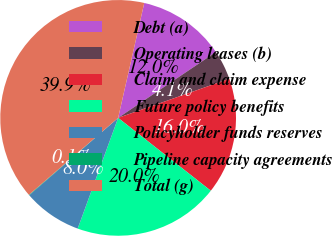Convert chart. <chart><loc_0><loc_0><loc_500><loc_500><pie_chart><fcel>Debt (a)<fcel>Operating leases (b)<fcel>Claim and claim expense<fcel>Future policy benefits<fcel>Policyholder funds reserves<fcel>Pipeline capacity agreements<fcel>Total (g)<nl><fcel>12.01%<fcel>4.05%<fcel>15.99%<fcel>19.97%<fcel>8.03%<fcel>0.07%<fcel>39.88%<nl></chart> 